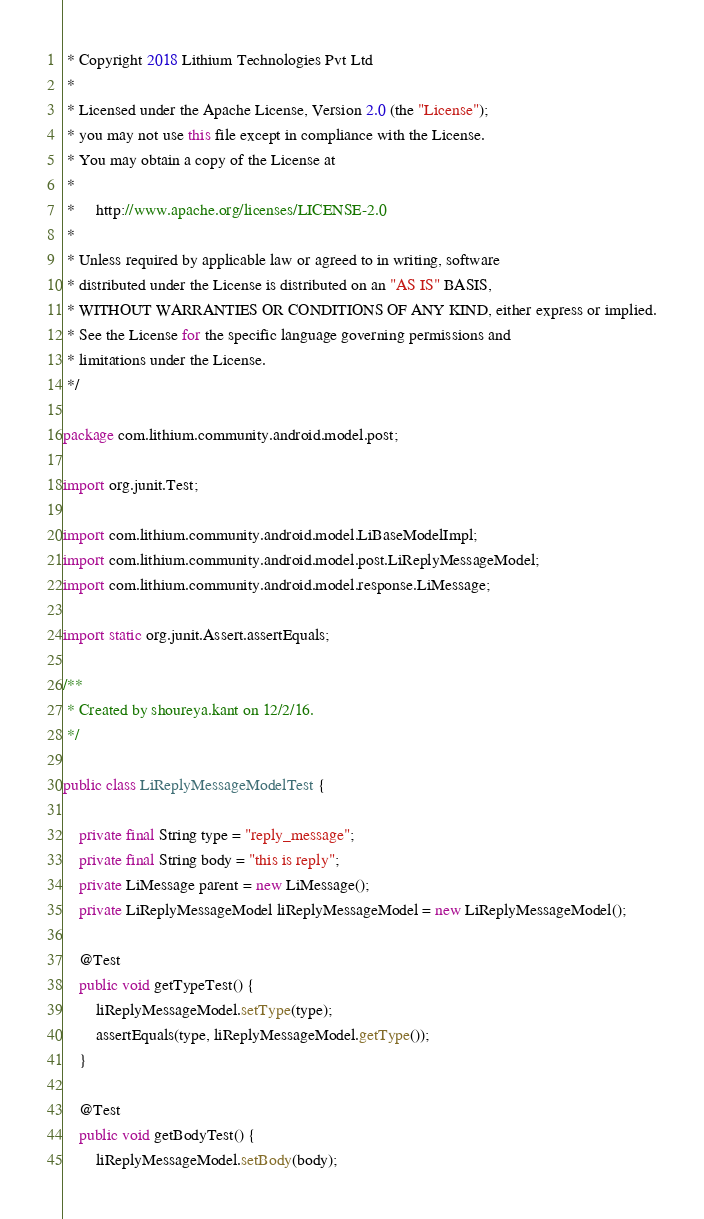Convert code to text. <code><loc_0><loc_0><loc_500><loc_500><_Java_> * Copyright 2018 Lithium Technologies Pvt Ltd
 *
 * Licensed under the Apache License, Version 2.0 (the "License");
 * you may not use this file except in compliance with the License.
 * You may obtain a copy of the License at
 *
 *     http://www.apache.org/licenses/LICENSE-2.0
 *
 * Unless required by applicable law or agreed to in writing, software
 * distributed under the License is distributed on an "AS IS" BASIS,
 * WITHOUT WARRANTIES OR CONDITIONS OF ANY KIND, either express or implied.
 * See the License for the specific language governing permissions and
 * limitations under the License.
 */

package com.lithium.community.android.model.post;

import org.junit.Test;

import com.lithium.community.android.model.LiBaseModelImpl;
import com.lithium.community.android.model.post.LiReplyMessageModel;
import com.lithium.community.android.model.response.LiMessage;

import static org.junit.Assert.assertEquals;

/**
 * Created by shoureya.kant on 12/2/16.
 */

public class LiReplyMessageModelTest {

    private final String type = "reply_message";
    private final String body = "this is reply";
    private LiMessage parent = new LiMessage();
    private LiReplyMessageModel liReplyMessageModel = new LiReplyMessageModel();

    @Test
    public void getTypeTest() {
        liReplyMessageModel.setType(type);
        assertEquals(type, liReplyMessageModel.getType());
    }

    @Test
    public void getBodyTest() {
        liReplyMessageModel.setBody(body);</code> 